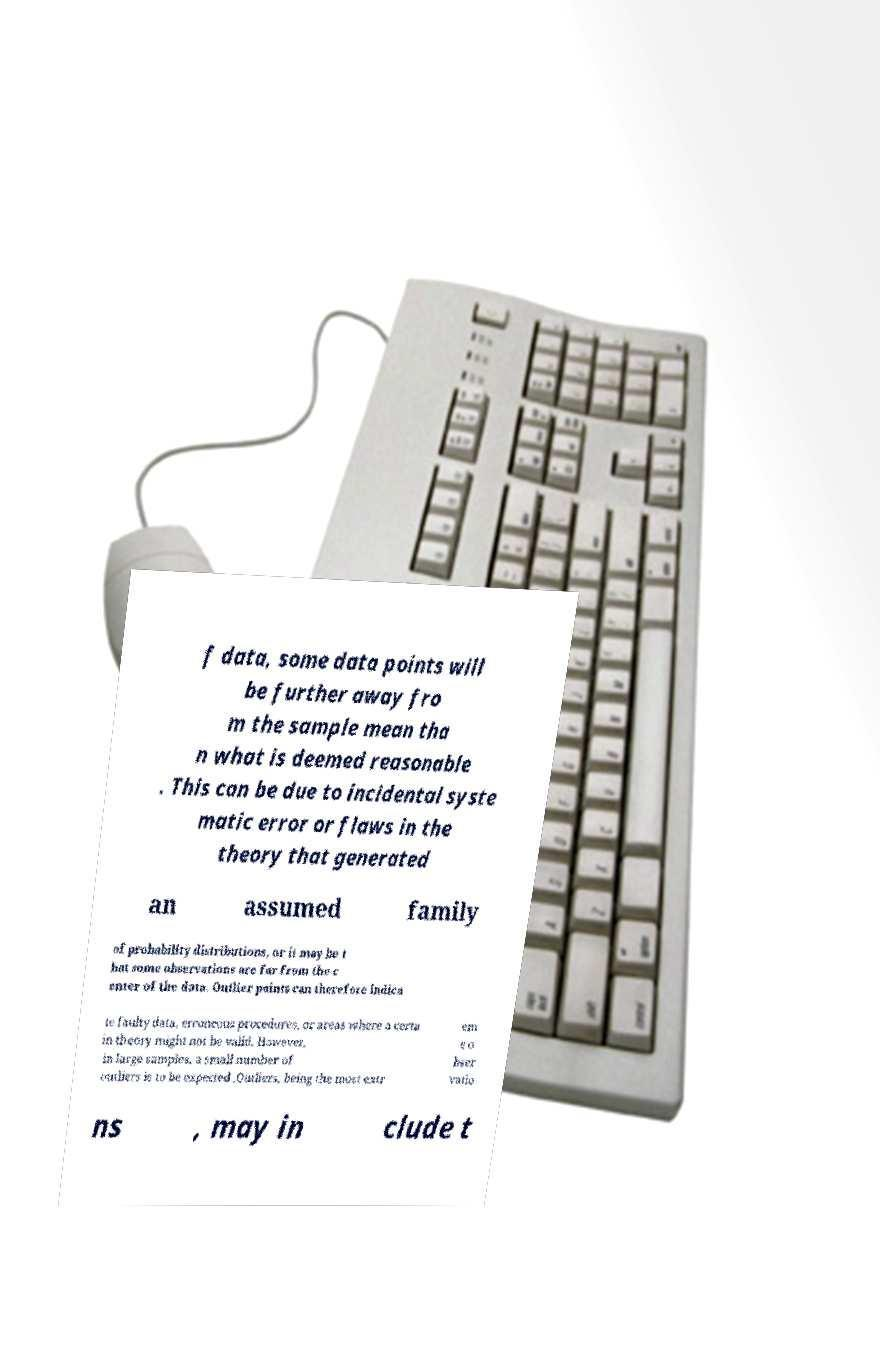What messages or text are displayed in this image? I need them in a readable, typed format. f data, some data points will be further away fro m the sample mean tha n what is deemed reasonable . This can be due to incidental syste matic error or flaws in the theory that generated an assumed family of probability distributions, or it may be t hat some observations are far from the c enter of the data. Outlier points can therefore indica te faulty data, erroneous procedures, or areas where a certa in theory might not be valid. However, in large samples, a small number of outliers is to be expected .Outliers, being the most extr em e o bser vatio ns , may in clude t 